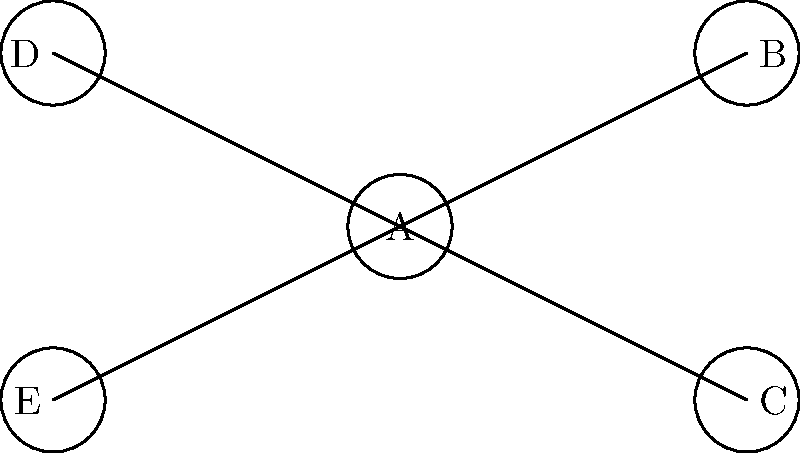In the network diagram above, node A represents a biofeedback device used for stress management. If nodes B and C represent heart rate monitors and blood pressure cuffs respectively, which of the remaining nodes is most likely to represent a portable EEG device for measuring brain activity during relaxation techniques? To answer this question, let's analyze the information given and the typical equipment used in stress management techniques:

1. Node A is identified as a biofeedback device, which is a central tool in many stress management techniques.

2. Nodes B and C are identified as heart rate monitors and blood pressure cuffs, respectively. These are common physiological measurement tools used in stress management.

3. The question asks about a portable EEG device, which is used to measure brain activity during relaxation techniques.

4. In stress management, EEG devices are often used alongside other physiological measurement tools to provide a comprehensive view of the body's stress response.

5. EEG devices are typically more advanced and specialized than heart rate monitors or blood pressure cuffs.

6. In the network diagram, nodes D and E are the remaining unidentified nodes.

7. Given that an EEG device is more specialized and would likely be introduced later in a stress management program, it would make sense for it to be slightly less central in the network.

8. Node D is positioned slightly further from the central node A compared to nodes B and C, making it the most likely candidate to represent the portable EEG device.

Therefore, node D is the most likely to represent a portable EEG device for measuring brain activity during relaxation techniques.
Answer: D 